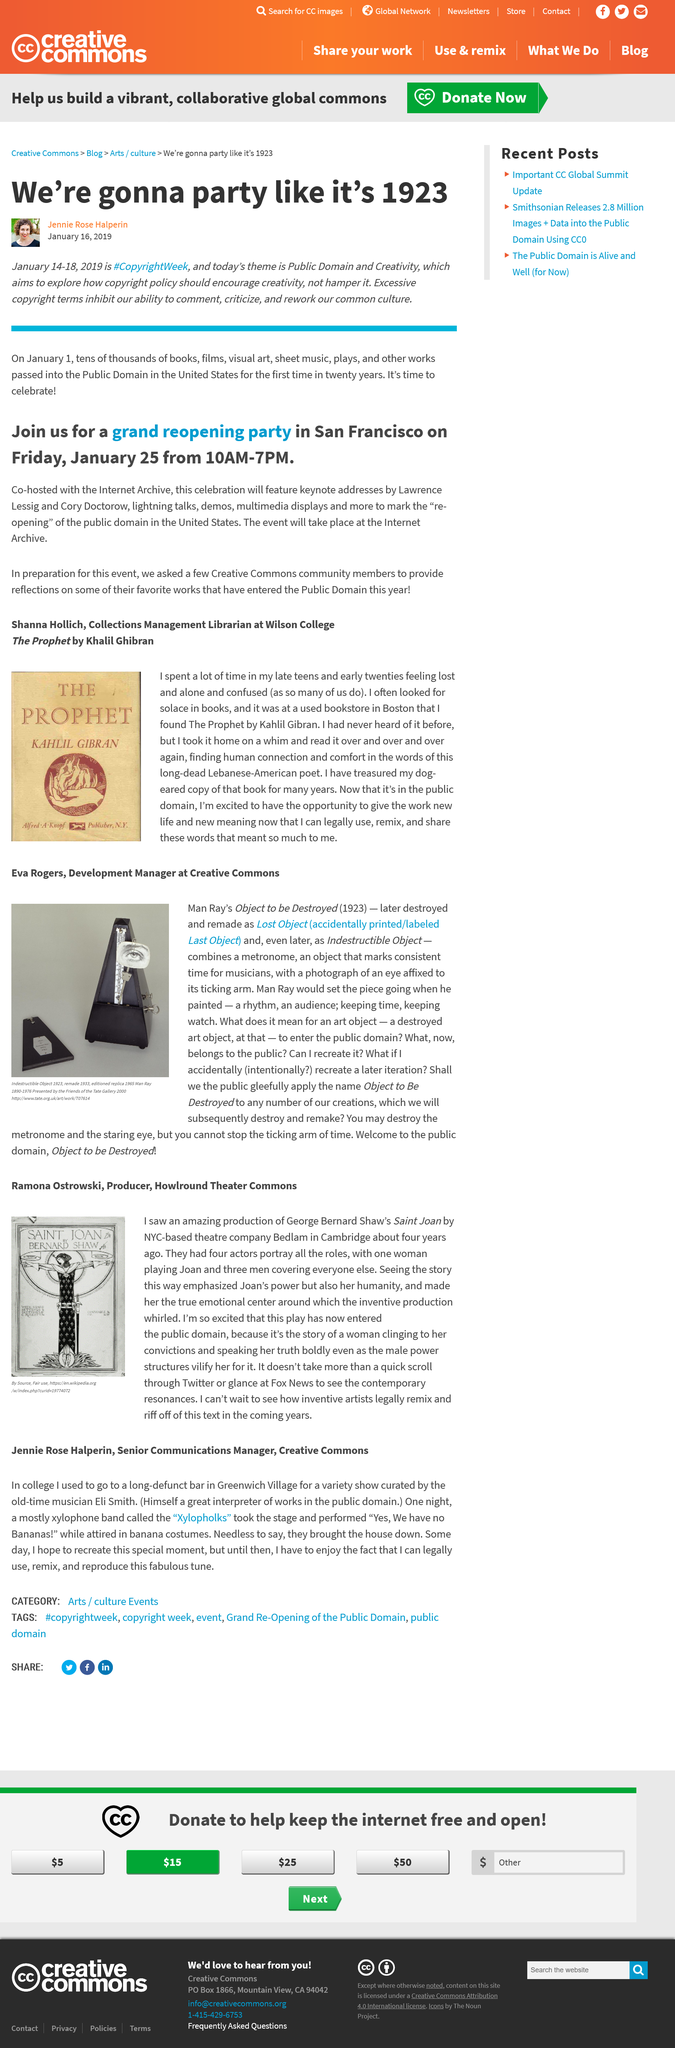List a handful of essential elements in this visual. The production was observed in Cambridge, as stated by the author in the text. The event known as #CopyrightWeek is scheduled to take place from January 14-18, 2019. The event will take place at the Internet Archive. The speaker declares that Joan is the true emotional center of the play, as stated by the author. In 1933, the Indestructible Object was remade. 